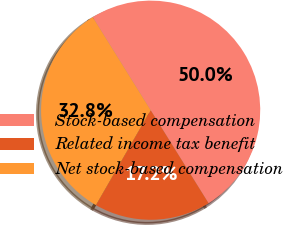Convert chart to OTSL. <chart><loc_0><loc_0><loc_500><loc_500><pie_chart><fcel>Stock-based compensation<fcel>Related income tax benefit<fcel>Net stock-based compensation<nl><fcel>50.0%<fcel>17.18%<fcel>32.82%<nl></chart> 